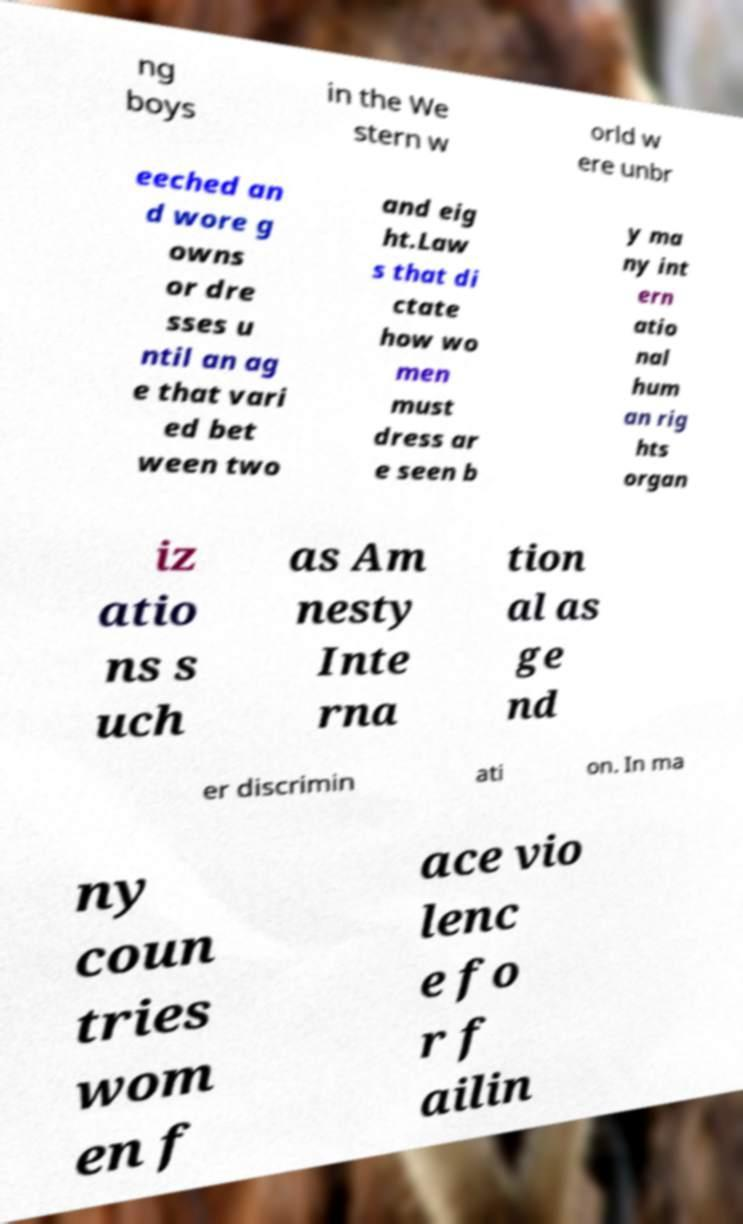Please identify and transcribe the text found in this image. ng boys in the We stern w orld w ere unbr eeched an d wore g owns or dre sses u ntil an ag e that vari ed bet ween two and eig ht.Law s that di ctate how wo men must dress ar e seen b y ma ny int ern atio nal hum an rig hts organ iz atio ns s uch as Am nesty Inte rna tion al as ge nd er discrimin ati on. In ma ny coun tries wom en f ace vio lenc e fo r f ailin 